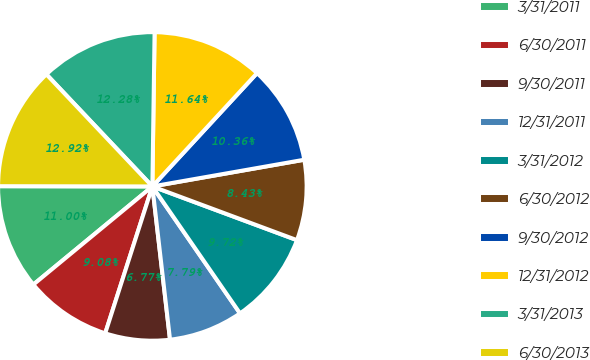<chart> <loc_0><loc_0><loc_500><loc_500><pie_chart><fcel>3/31/2011<fcel>6/30/2011<fcel>9/30/2011<fcel>12/31/2011<fcel>3/31/2012<fcel>6/30/2012<fcel>9/30/2012<fcel>12/31/2012<fcel>3/31/2013<fcel>6/30/2013<nl><fcel>11.0%<fcel>9.08%<fcel>6.77%<fcel>7.79%<fcel>9.72%<fcel>8.43%<fcel>10.36%<fcel>11.64%<fcel>12.28%<fcel>12.92%<nl></chart> 